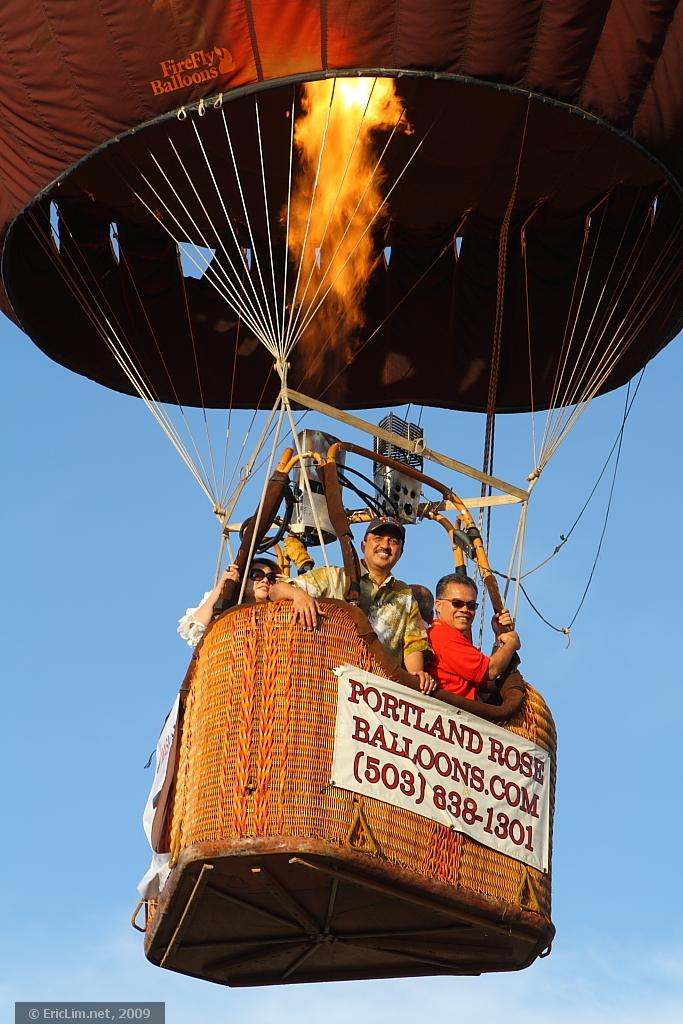Provide a one-sentence caption for the provided image. A group of people are taking a balloon ride from Portland Rose Balloons.com. 